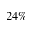<formula> <loc_0><loc_0><loc_500><loc_500>2 4 \%</formula> 